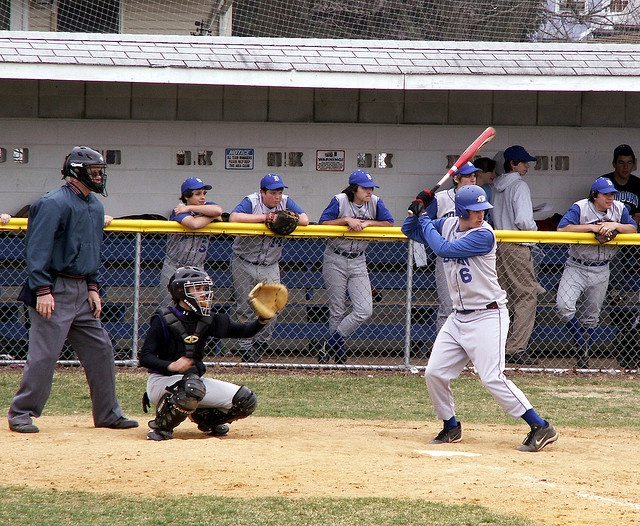Describe the objects in this image and their specific colors. I can see people in black, gray, and darkblue tones, people in black, lavender, darkgray, and navy tones, people in black, gray, darkgray, and lightgray tones, people in black and gray tones, and people in black and gray tones in this image. 